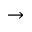Convert formula to latex. <formula><loc_0><loc_0><loc_500><loc_500>\rightarrow</formula> 